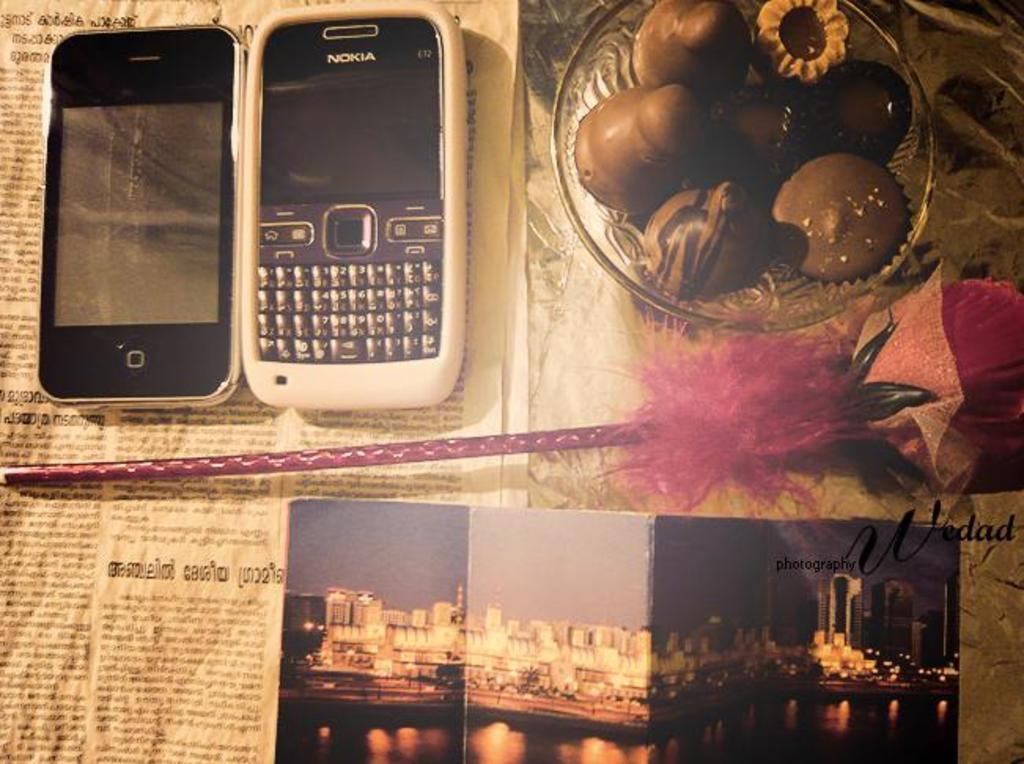<image>
Offer a succinct explanation of the picture presented. Nokia phone on top of a newspaper article. 